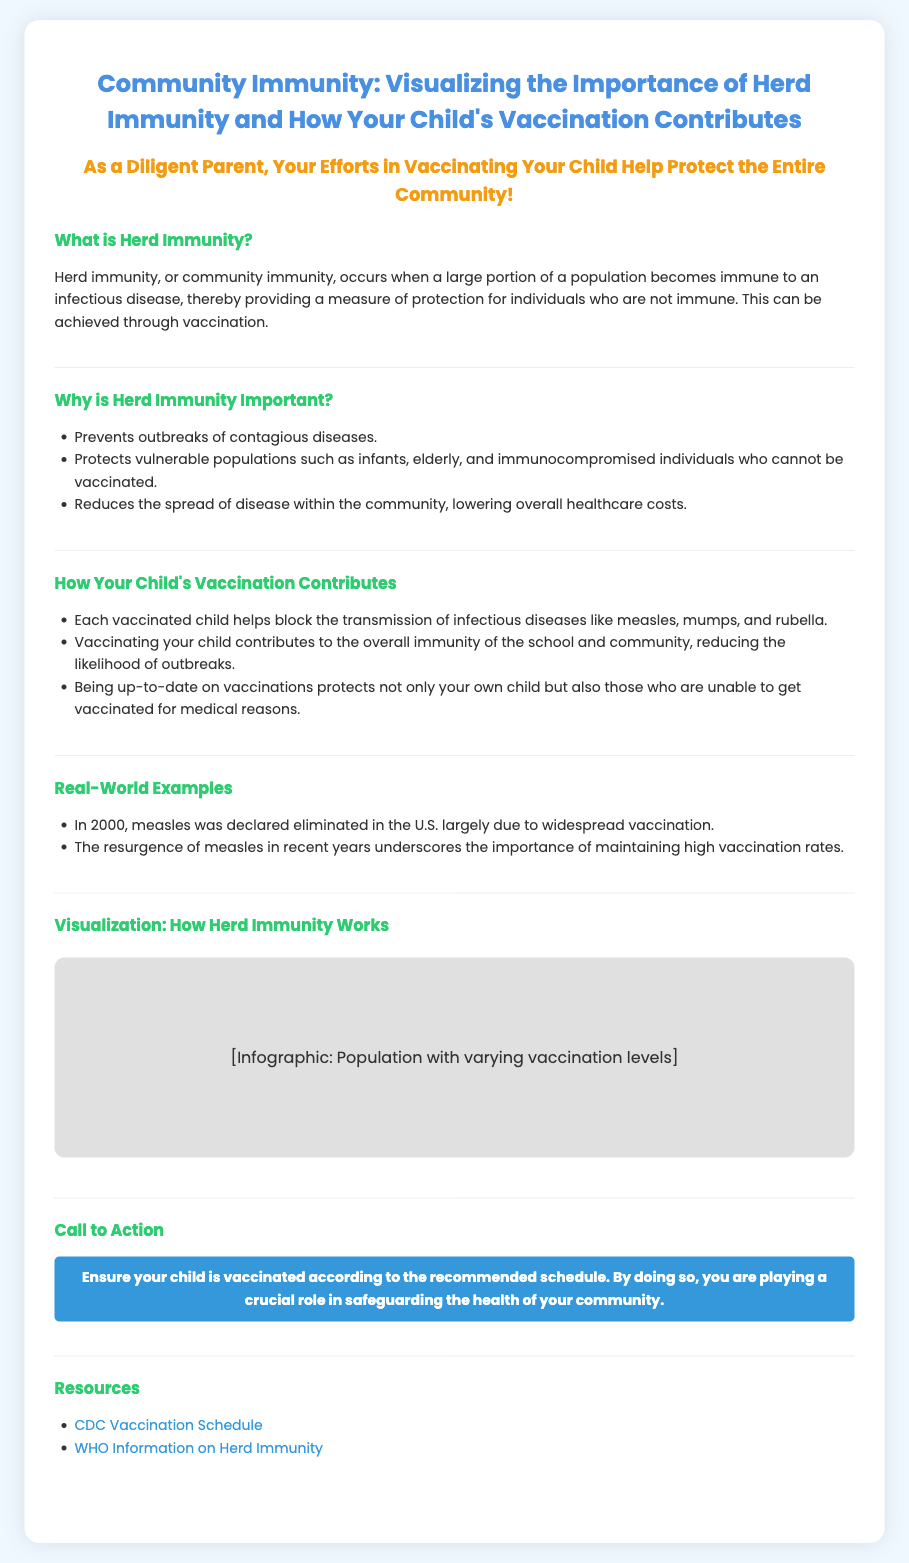What is herd immunity? Herd immunity is defined in the document as when a large portion of a population becomes immune to an infectious disease, providing protection for those who are not immune.
Answer: A large portion of a population becomes immune to an infectious disease Why is herd immunity important? The document lists several reasons why herd immunity is important, including preventing outbreaks and protecting vulnerable populations.
Answer: Prevents outbreaks of contagious diseases What does each vaccinated child help block? The document states that each vaccinated child helps block the transmission of infectious diseases.
Answer: The transmission of infectious diseases When was measles declared eliminated in the U.S.? The document mentions that measles was declared eliminated in the U.S. in the year 2000 due to widespread vaccination.
Answer: 2000 What does the visualization in the poster show? The document refers to an infographic that illustrates population with varying vaccination levels, indicating how herd immunity works.
Answer: Population with varying vaccination levels 